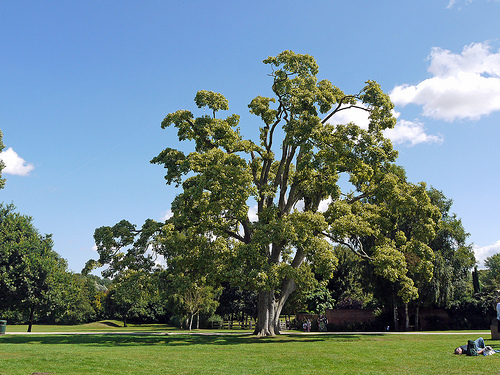<image>
Is the tree on the grass? Yes. Looking at the image, I can see the tree is positioned on top of the grass, with the grass providing support. 